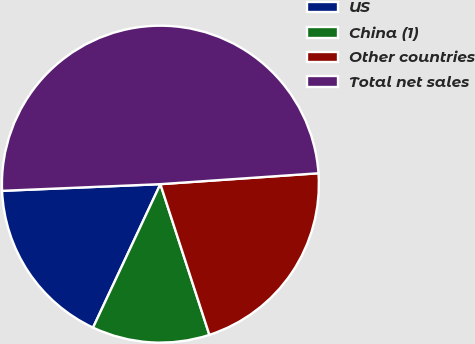<chart> <loc_0><loc_0><loc_500><loc_500><pie_chart><fcel>US<fcel>China (1)<fcel>Other countries<fcel>Total net sales<nl><fcel>17.34%<fcel>11.99%<fcel>21.09%<fcel>49.57%<nl></chart> 